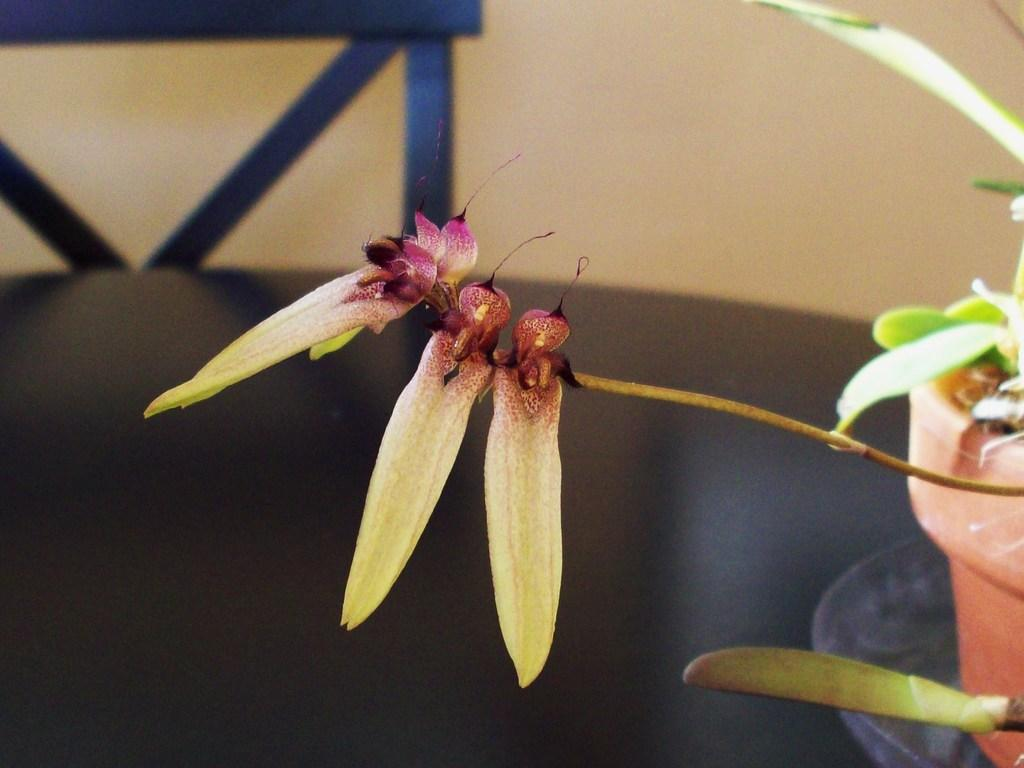What type of plant can be seen in the image? There is a houseplant in the image. What is located on the table in the image? There is a glass bowl on a table in the image. What type of furniture is present in the image? There is a chair in the image. How would you describe the background of the image? The background of the image has a creamy appearance. What type of work is the person doing in the image? There is no person present in the image, so no work can be observed. How many days of the week are depicted in the image? There is no reference to days of the week in the image, so it cannot be determined. 